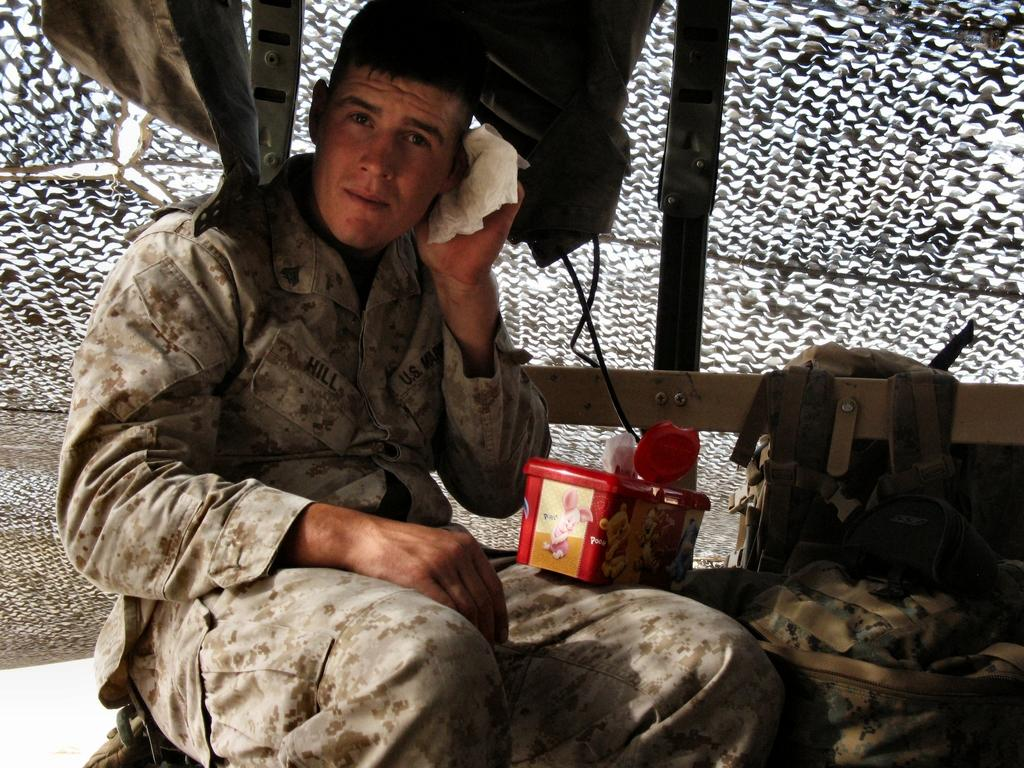What is the man in the image doing? The man is sitting in the image. What is the man holding in the image? The man is holding a cloth in the image. What is on the man's leg in the image? There is a box on the man's leg in the image. What else can be seen in the image besides the man? There are bags visible in the image, as well as a mesh. What type of trousers is the man wearing in the image? The provided facts do not mention the man's trousers, so we cannot determine the type of trousers he is wearing in the image. 